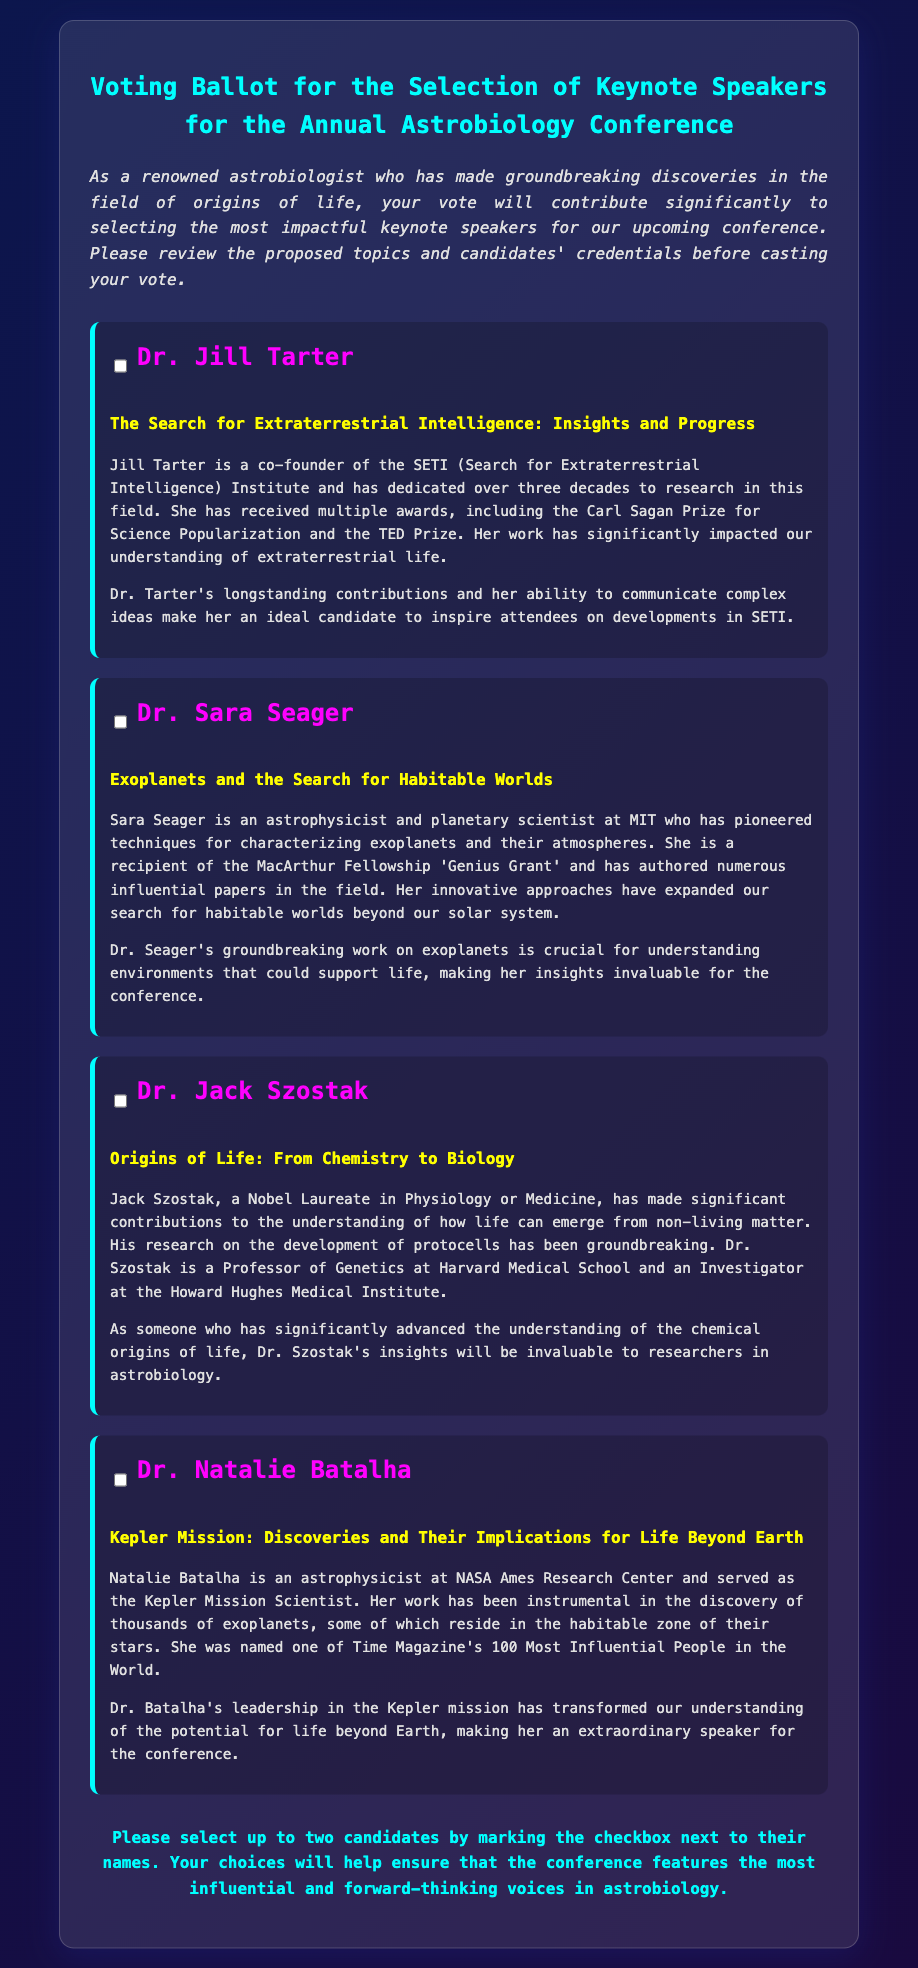What is the title of the document? The title of the document is displayed prominently at the top, indicating its purpose.
Answer: Voting Ballot for the Selection of Keynote Speakers for the Annual Astrobiology Conference Who is the first candidate listed? The first candidate is identified in the candidate section under their name.
Answer: Dr. Jill Tarter What topic does Dr. Sara Seager cover? The topic is outlined directly beneath her name in the candidate information.
Answer: Exoplanets and the Search for Habitable Worlds Which award has Dr. Jack Szostak received? The document mentions significant achievements within the credentials section for Jack Szostak.
Answer: Nobel Prize How many candidates can be selected? The instructions section specifies the number of candidates that can be chosen by the voter.
Answer: Two What is the significance of the Kepler Mission, according to Dr. Natalie Batalha? This can be found in the summary of her credentials and why she should be considered as a speaker.
Answer: Transform our understanding of the potential for life beyond Earth Who is the audience for this ballot? The introduction specifies who the intended voters are, indicating their expertise level.
Answer: Renowned astrobiologists What is the main purpose of this document? The overall aim of the document is specified in the introductory paragraph.
Answer: To select keynote speakers for the conference 